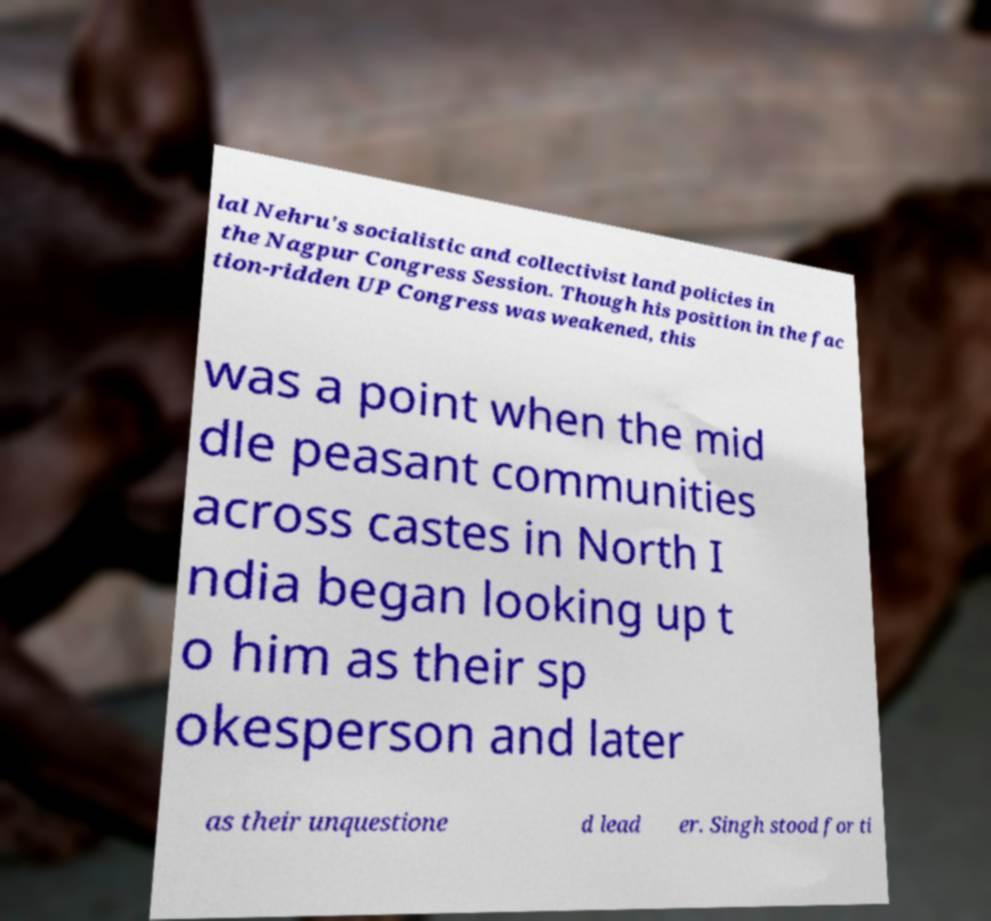Can you read and provide the text displayed in the image?This photo seems to have some interesting text. Can you extract and type it out for me? lal Nehru's socialistic and collectivist land policies in the Nagpur Congress Session. Though his position in the fac tion-ridden UP Congress was weakened, this was a point when the mid dle peasant communities across castes in North I ndia began looking up t o him as their sp okesperson and later as their unquestione d lead er. Singh stood for ti 